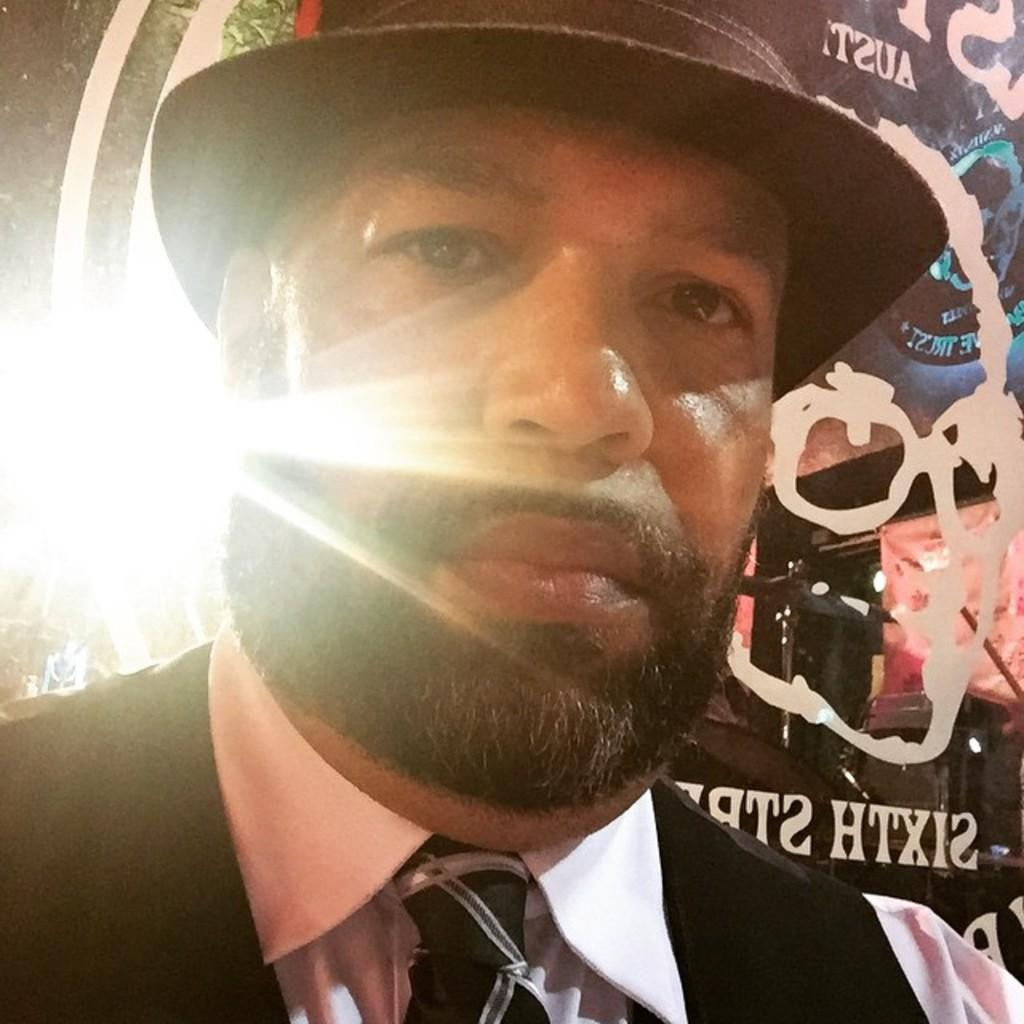What is the main subject in the foreground of the image? There is a man in the foreground of the image. What can be seen behind the man in the image? There is a poster visible behind the man. What type of gun is the man holding in the image? There is no gun present in the image; the man is not holding any object. 